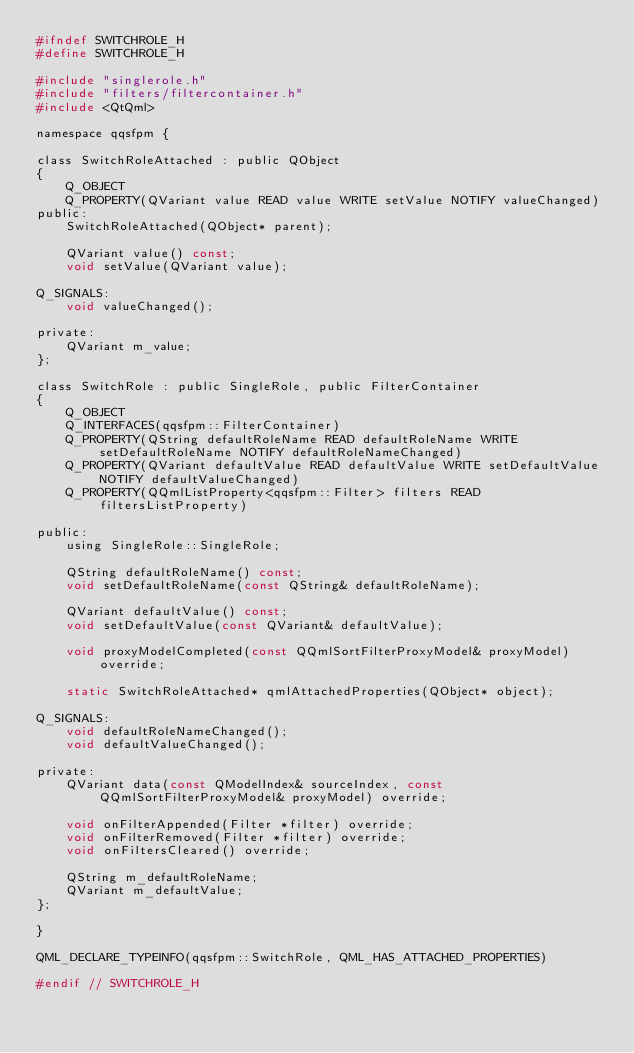<code> <loc_0><loc_0><loc_500><loc_500><_C_>#ifndef SWITCHROLE_H
#define SWITCHROLE_H

#include "singlerole.h"
#include "filters/filtercontainer.h"
#include <QtQml>

namespace qqsfpm {

class SwitchRoleAttached : public QObject
{
    Q_OBJECT
    Q_PROPERTY(QVariant value READ value WRITE setValue NOTIFY valueChanged)
public:
    SwitchRoleAttached(QObject* parent);

    QVariant value() const;
    void setValue(QVariant value);

Q_SIGNALS:
    void valueChanged();

private:
    QVariant m_value;
};

class SwitchRole : public SingleRole, public FilterContainer
{
    Q_OBJECT
    Q_INTERFACES(qqsfpm::FilterContainer)
    Q_PROPERTY(QString defaultRoleName READ defaultRoleName WRITE setDefaultRoleName NOTIFY defaultRoleNameChanged)
    Q_PROPERTY(QVariant defaultValue READ defaultValue WRITE setDefaultValue NOTIFY defaultValueChanged)
    Q_PROPERTY(QQmlListProperty<qqsfpm::Filter> filters READ filtersListProperty)

public:
    using SingleRole::SingleRole;

    QString defaultRoleName() const;
    void setDefaultRoleName(const QString& defaultRoleName);

    QVariant defaultValue() const;
    void setDefaultValue(const QVariant& defaultValue);

    void proxyModelCompleted(const QQmlSortFilterProxyModel& proxyModel) override;

    static SwitchRoleAttached* qmlAttachedProperties(QObject* object);

Q_SIGNALS:
    void defaultRoleNameChanged();
    void defaultValueChanged();

private:
    QVariant data(const QModelIndex& sourceIndex, const QQmlSortFilterProxyModel& proxyModel) override;

    void onFilterAppended(Filter *filter) override;
    void onFilterRemoved(Filter *filter) override;
    void onFiltersCleared() override;

    QString m_defaultRoleName;
    QVariant m_defaultValue;
};

}

QML_DECLARE_TYPEINFO(qqsfpm::SwitchRole, QML_HAS_ATTACHED_PROPERTIES)

#endif // SWITCHROLE_H
</code> 